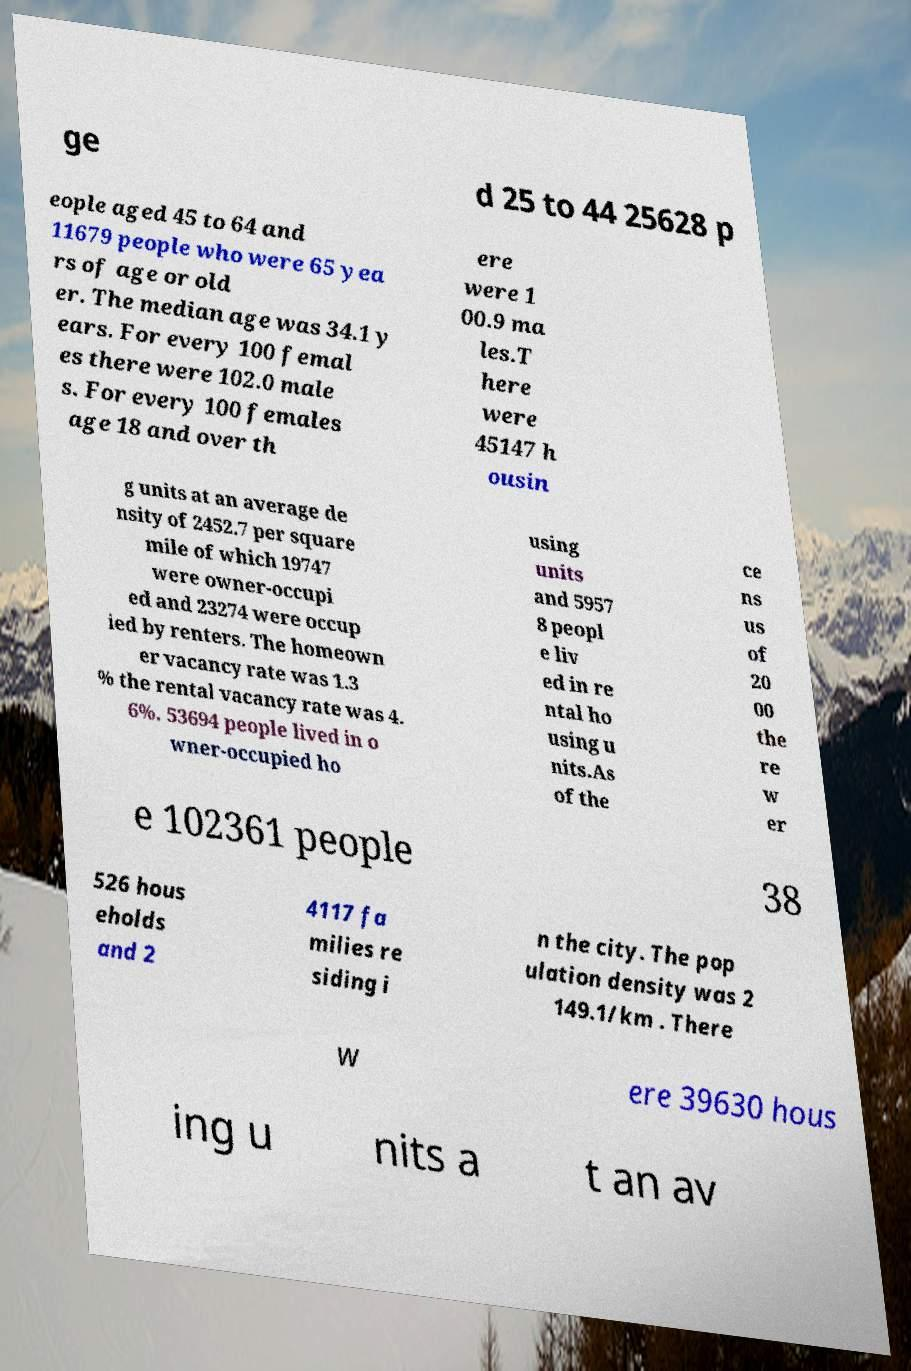There's text embedded in this image that I need extracted. Can you transcribe it verbatim? ge d 25 to 44 25628 p eople aged 45 to 64 and 11679 people who were 65 yea rs of age or old er. The median age was 34.1 y ears. For every 100 femal es there were 102.0 male s. For every 100 females age 18 and over th ere were 1 00.9 ma les.T here were 45147 h ousin g units at an average de nsity of 2452.7 per square mile of which 19747 were owner-occupi ed and 23274 were occup ied by renters. The homeown er vacancy rate was 1.3 % the rental vacancy rate was 4. 6%. 53694 people lived in o wner-occupied ho using units and 5957 8 peopl e liv ed in re ntal ho using u nits.As of the ce ns us of 20 00 the re w er e 102361 people 38 526 hous eholds and 2 4117 fa milies re siding i n the city. The pop ulation density was 2 149.1/km . There w ere 39630 hous ing u nits a t an av 